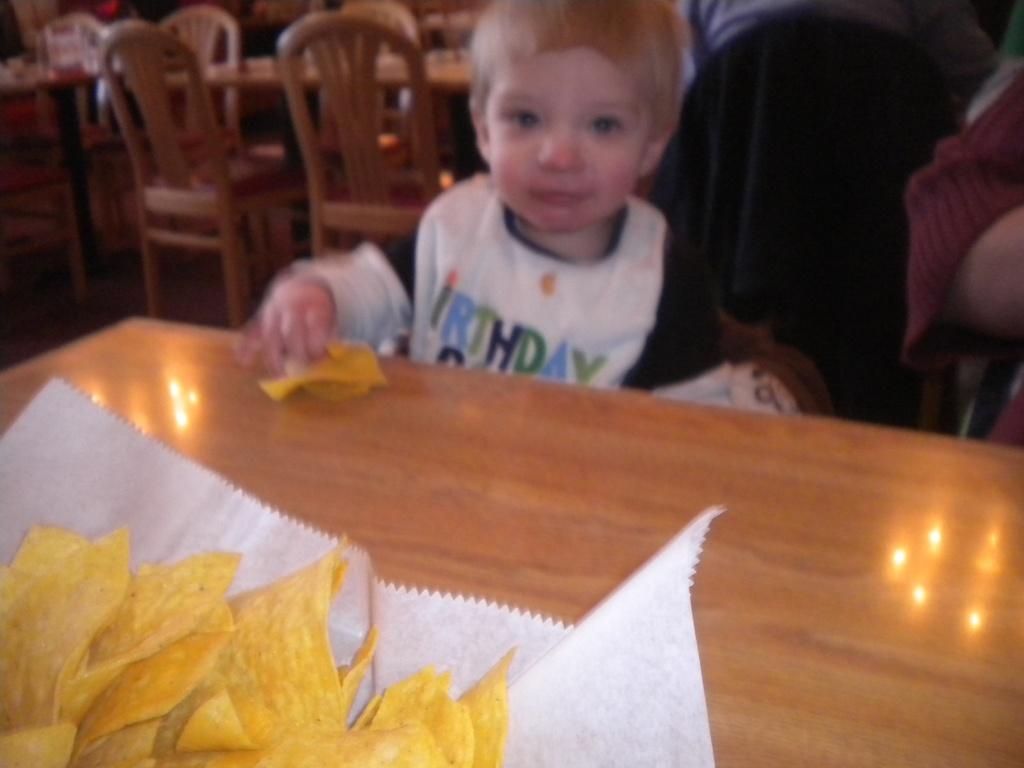Can you describe this image briefly? This is the blurred picture of a little boy who is holding chips and standing in front of a table on which there are some chips on the tissue. 